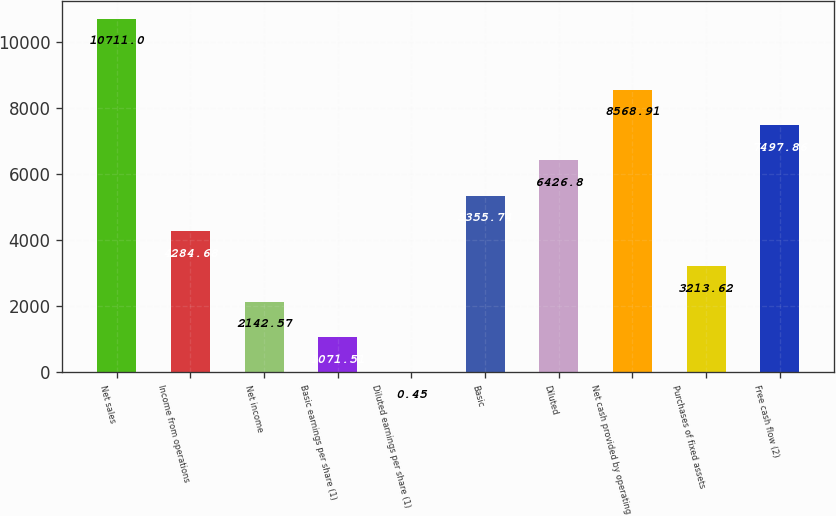Convert chart. <chart><loc_0><loc_0><loc_500><loc_500><bar_chart><fcel>Net sales<fcel>Income from operations<fcel>Net income<fcel>Basic earnings per share (1)<fcel>Diluted earnings per share (1)<fcel>Basic<fcel>Diluted<fcel>Net cash provided by operating<fcel>Purchases of fixed assets<fcel>Free cash flow (2)<nl><fcel>10711<fcel>4284.68<fcel>2142.57<fcel>1071.51<fcel>0.45<fcel>5355.74<fcel>6426.8<fcel>8568.91<fcel>3213.62<fcel>7497.86<nl></chart> 